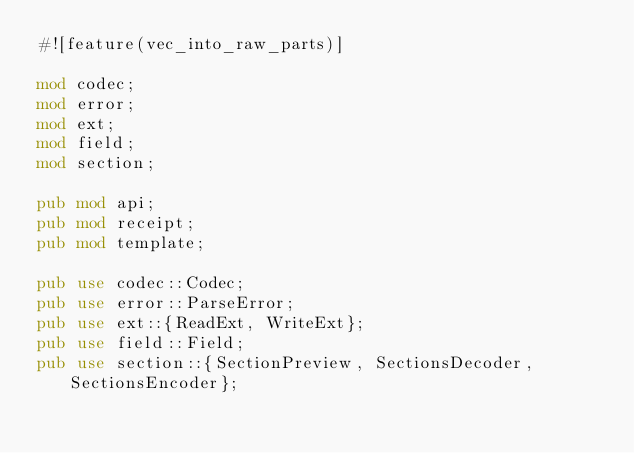Convert code to text. <code><loc_0><loc_0><loc_500><loc_500><_Rust_>#![feature(vec_into_raw_parts)]

mod codec;
mod error;
mod ext;
mod field;
mod section;

pub mod api;
pub mod receipt;
pub mod template;

pub use codec::Codec;
pub use error::ParseError;
pub use ext::{ReadExt, WriteExt};
pub use field::Field;
pub use section::{SectionPreview, SectionsDecoder, SectionsEncoder};
</code> 